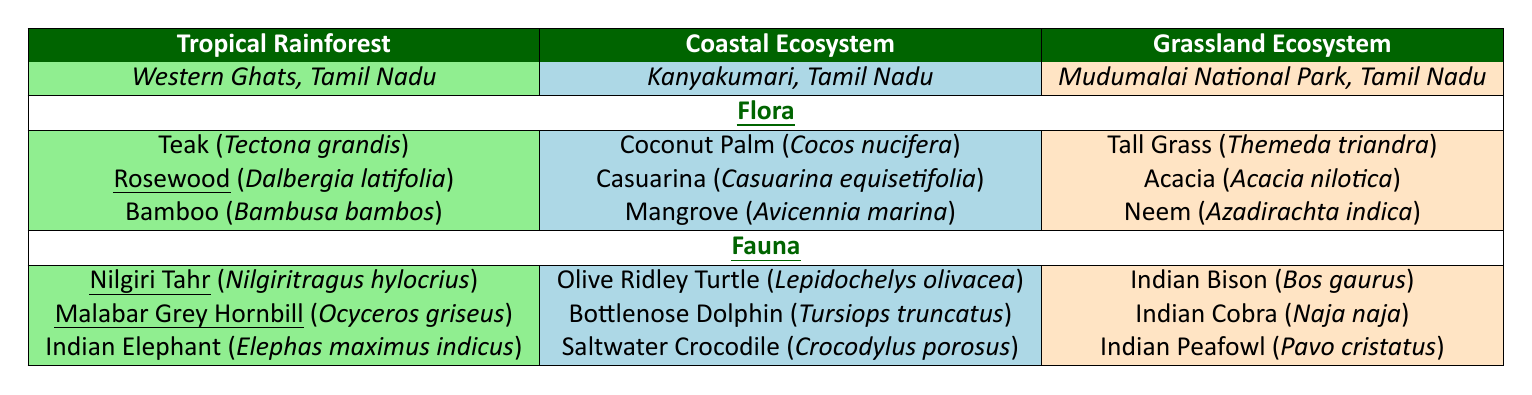What are the three types of flora in the Tropical Rainforest? From the table, under the Tropical Rainforest section, the three types of flora listed are Teak, Rosewood, and Bamboo.
Answer: Teak, Rosewood, Bamboo Which ecosystem has the most endemic fauna? In the Tropical Rainforest ecosystem, there are two endemic fauna (Nilgiri Tahr and Malabar Grey Hornbill). The Coastal and Grassland ecosystems have no endemic fauna. Thus, the only ecosystem with endemic fauna is Tropical Rainforest.
Answer: Tropical Rainforest Is the Indian Elephant endemic to the Tropical Rainforest? The table lists the Indian Elephant under the Tropical Rainforest fauna, but it indicates that it is not endemic. Therefore, the answer is no.
Answer: No How many endemic plants are found in the Coastal Ecosystem? According to the table, all flora listed in the Coastal Ecosystem (Coconut Palm, Casuarina, Mangrove) are marked as non-endemic. Thus, there are zero endemic plants.
Answer: Zero Count the total number of flora across all ecosystems. In the Tropical Rainforest, there are 3 flora; in the Coastal Ecosystem, there are 3; and in the Grassland Ecosystem, there are also 3. Adding these gives 3 + 3 + 3 = 9.
Answer: 9 Which flora is common between the ecosystems? After examining the data, there are no flora species that are common across the three ecosystems listed because each ecosystem has distinct species.
Answer: None Which ecosystem contains the Indian Peafowl? The Indian Peafowl is listed under the Grassland Ecosystem in the fauna section.
Answer: Grassland Ecosystem Are there more flora or fauna in the Coastal Ecosystem? The Coastal Ecosystem contains 3 flora (Coconut Palm, Casuarina, Mangrove) and 3 fauna (Olive Ridley Turtle, Bottlenose Dolphin, Saltwater Crocodile). Thus, the number of flora and fauna is equal.
Answer: Equal List the scientific name of Rosewood. The table specifies that Rosewood is scientifically known as Dalbergia latifolia.
Answer: Dalbergia latifolia How many endemic species are there in the entire data set? In total, the Tropical Rainforest has 2 endemic fauna (Nilgiri Tahr, Malabar Grey Hornbill) and 1 endemic flora (Rosewood). There are no endemic species in the Coastal and Grassland ecosystems. Therefore, the total is 3 endemic species.
Answer: 3 